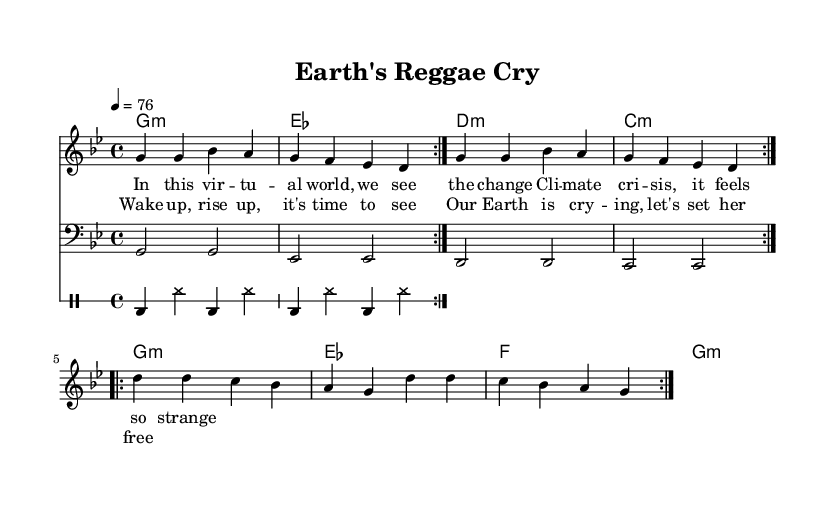What is the key signature of this music? The key signature is indicated at the beginning of the score, showing one flat, which corresponds to G minor.
Answer: G minor What is the time signature of this music? The time signature is displayed at the beginning of the score as 4/4, indicating four beats per measure.
Answer: 4/4 What is the tempo marking of this music? The tempo is specified in beats per minute at the beginning of the score, which shows 76 beats per minute.
Answer: 76 How many times is the melody repeated in the first section? The melody has a repeat sign, indicating that it is played two times in the first section before moving on.
Answer: 2 What is the primary theme addressed in the lyrics? The lyrics discuss climate change and the urgency of environmental awareness, emphasizing the need to act.
Answer: Climate change What type of rhythm pattern is used in the drum section? The drum section employs a repetitive pattern featuring bass drum and hi-hat, typical for reggae music, creating a laid-back groove.
Answer: Reggae rhythm What type of musical structure is used in the piece? The piece engages a verse-chorus structure, where verses are followed by a catchy chorus that embodies the message of the song.
Answer: Verse-chorus 